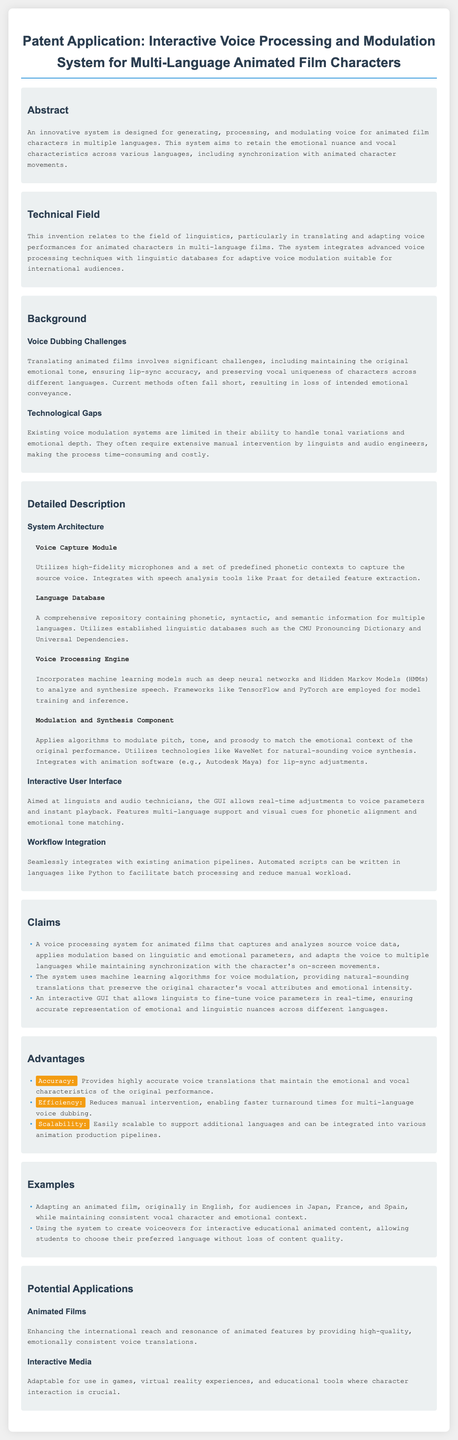What is the title of the patent application? The title is explicitly stated in the document and is "Interactive Voice Processing and Modulation System for Multi-Language Animated Film Characters."
Answer: Interactive Voice Processing and Modulation System for Multi-Language Animated Film Characters What category does this invention relate to? The document specifies the technical field which outlines the area of technology, here it is "linguistics."
Answer: linguistics What is the purpose of the voice processing system? The abstract outlines that the system aims to generate, process, and modulate voice for animated film characters in multiple languages.
Answer: generate, process, and modulate voice What challenges are mentioned in voice dubbing? The background section highlights challenges such as maintaining emotional tone, ensuring lip-sync accuracy, and preserving vocal uniqueness.
Answer: emotional tone, lip-sync accuracy, vocal uniqueness What type of algorithms does the system use for voice modulation? The claims section indicates that the system uses "machine learning algorithms" for this purpose.
Answer: machine learning algorithms How does the interactive user interface benefit linguists? The detailed description states that it allows "real-time adjustments" to voice parameters.
Answer: real-time adjustments In which environments can the system be applied? The document outlines potential applications including "animated films" and "interactive media."
Answer: animated films, interactive media What kind of microphone does the Voice Capture Module utilize? The detailed description mentions the use of "high-fidelity microphones" to capture voices.
Answer: high-fidelity microphones How does the system address integration with existing workflows? The workflow integration section specifies the use of "automated scripts" to facilitate integration.
Answer: automated scripts 